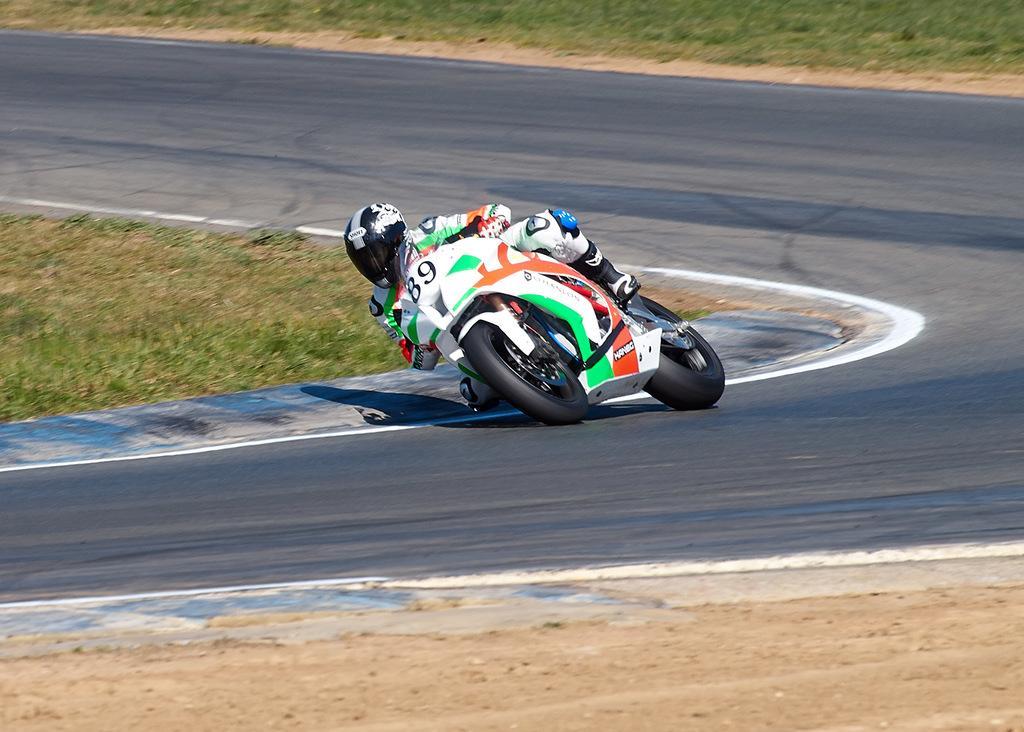In one or two sentences, can you explain what this image depicts? There is a person wearing gloves, knee pads and helmet is riding a motor cycle on a road. On the ground there is grass. 